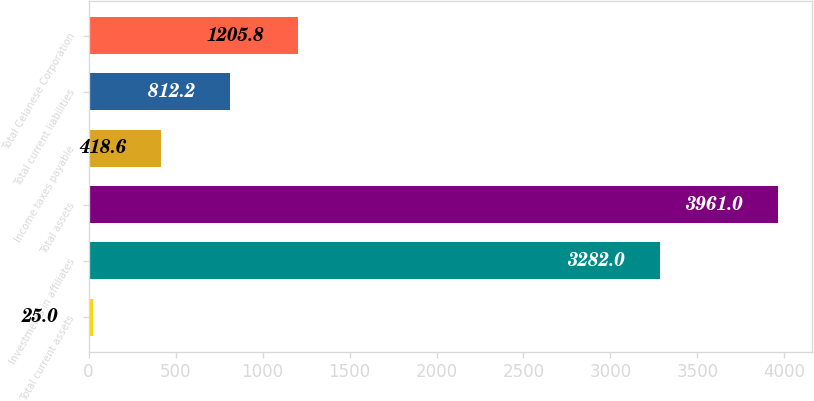Convert chart. <chart><loc_0><loc_0><loc_500><loc_500><bar_chart><fcel>Total current assets<fcel>Investments in affiliates<fcel>Total assets<fcel>Income taxes payable<fcel>Total current liabilities<fcel>Total Celanese Corporation<nl><fcel>25<fcel>3282<fcel>3961<fcel>418.6<fcel>812.2<fcel>1205.8<nl></chart> 